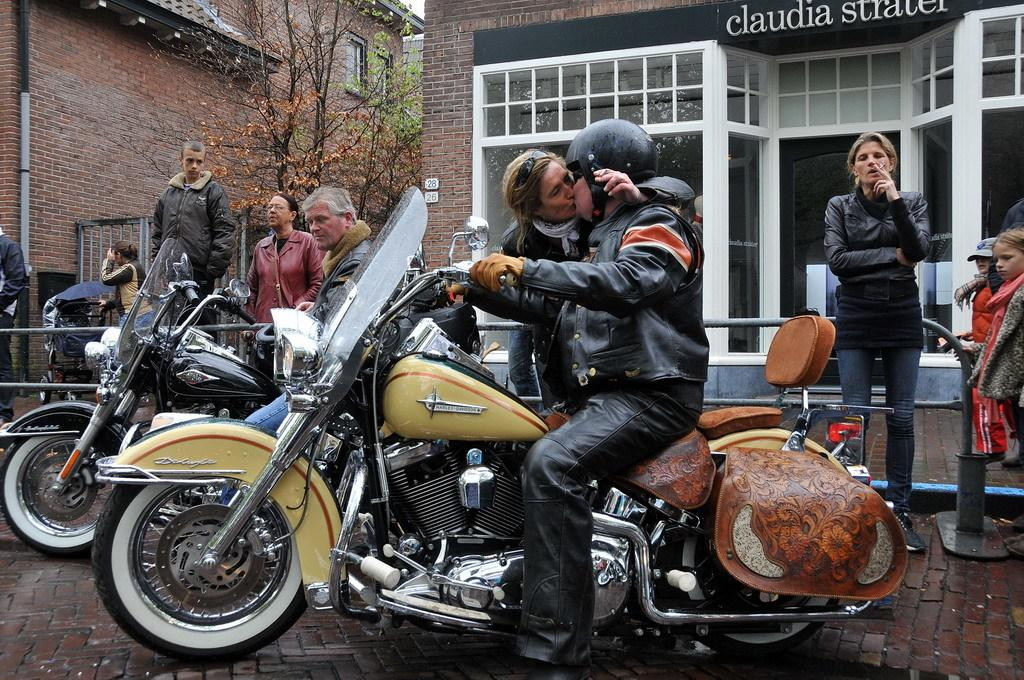What type of structures can be seen in the image? There are buildings in the image. What other natural elements are present in the image? There are trees in the image. Are there any living beings visible in the image? Yes, there are people in the image. What mode of transportation can be seen in the image? There are motorcycles in the image. What time of day is represented by the hour in the image? There is no hour present in the image, as it is a visual representation and not a clock or timepiece. What type of shock can be seen affecting the people in the image? There is no shock or any indication of distress visible in the image; the people appear to be going about their activities. 